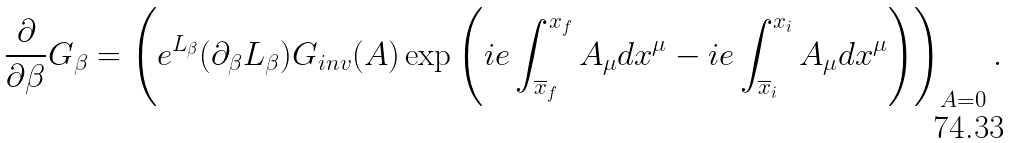<formula> <loc_0><loc_0><loc_500><loc_500>\frac { \partial } { \partial \beta } G _ { \beta } = \left ( e ^ { L _ { \beta } } ( \partial _ { \beta } L _ { \beta } ) G _ { i n v } ( A ) \exp \left ( i e \int ^ { x _ { f } } _ { \overline { x } _ { f } } A _ { \mu } d x ^ { \mu } - i e \int ^ { x _ { i } } _ { \overline { x } _ { i } } A _ { \mu } d x ^ { \mu } \right ) \right ) _ { A = 0 } .</formula> 